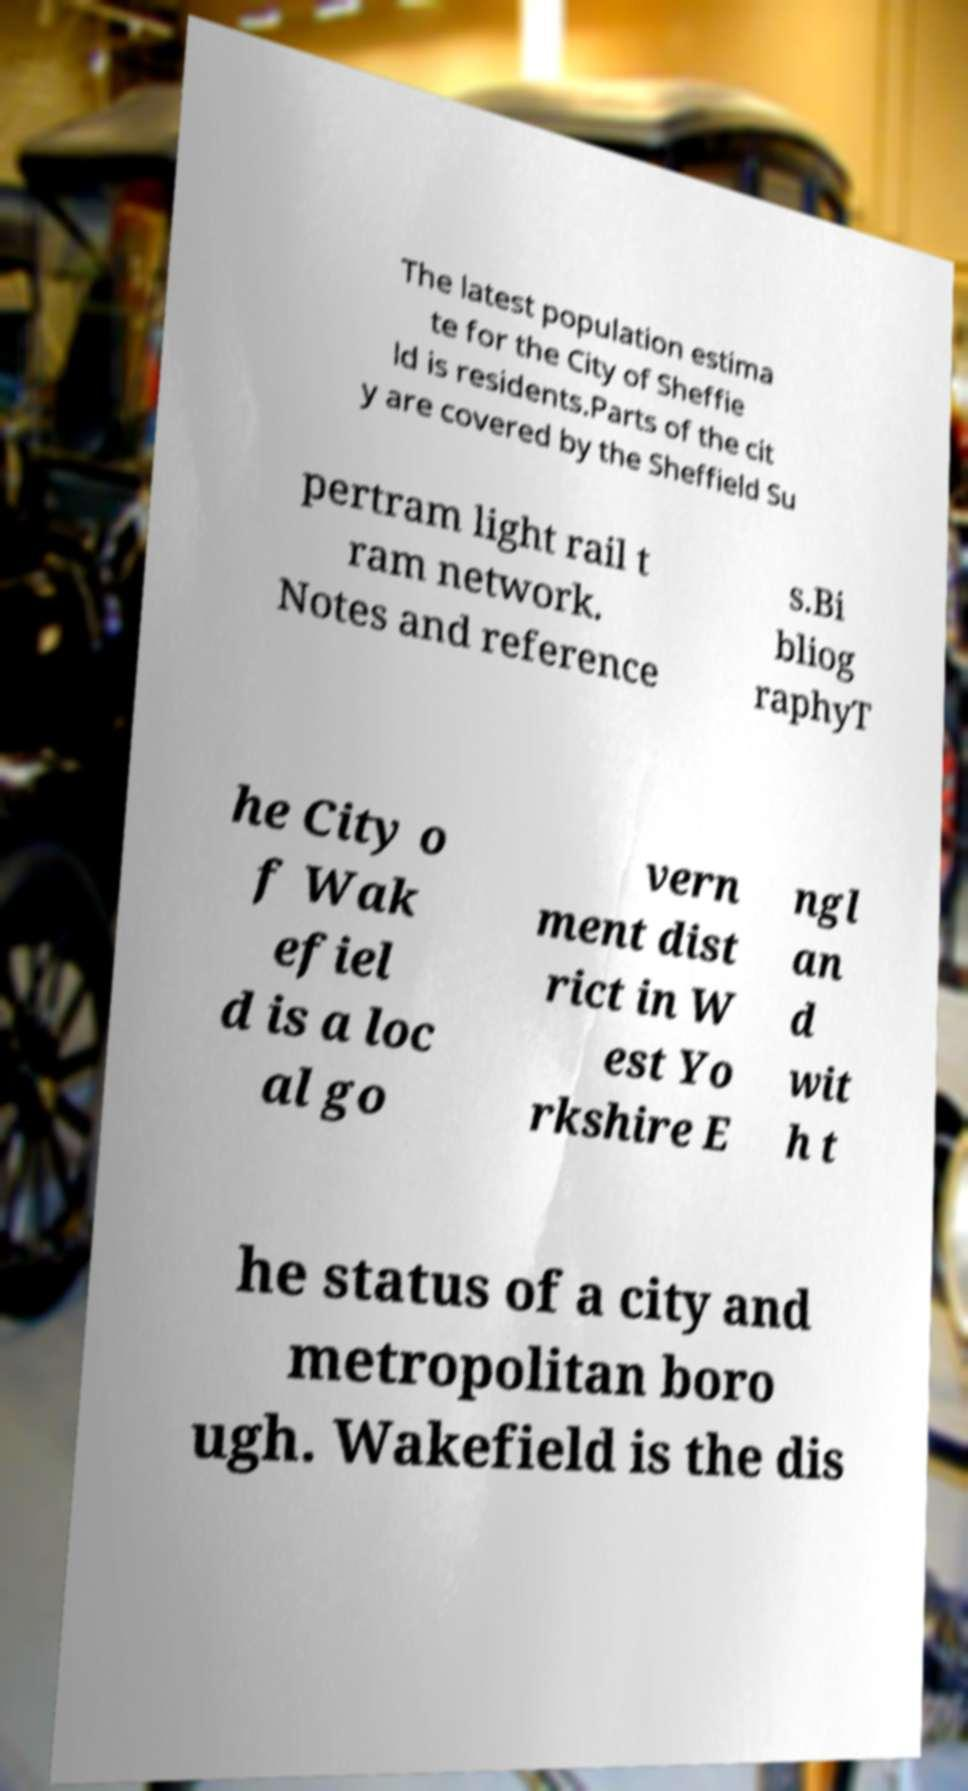I need the written content from this picture converted into text. Can you do that? The latest population estima te for the City of Sheffie ld is residents.Parts of the cit y are covered by the Sheffield Su pertram light rail t ram network. Notes and reference s.Bi bliog raphyT he City o f Wak efiel d is a loc al go vern ment dist rict in W est Yo rkshire E ngl an d wit h t he status of a city and metropolitan boro ugh. Wakefield is the dis 